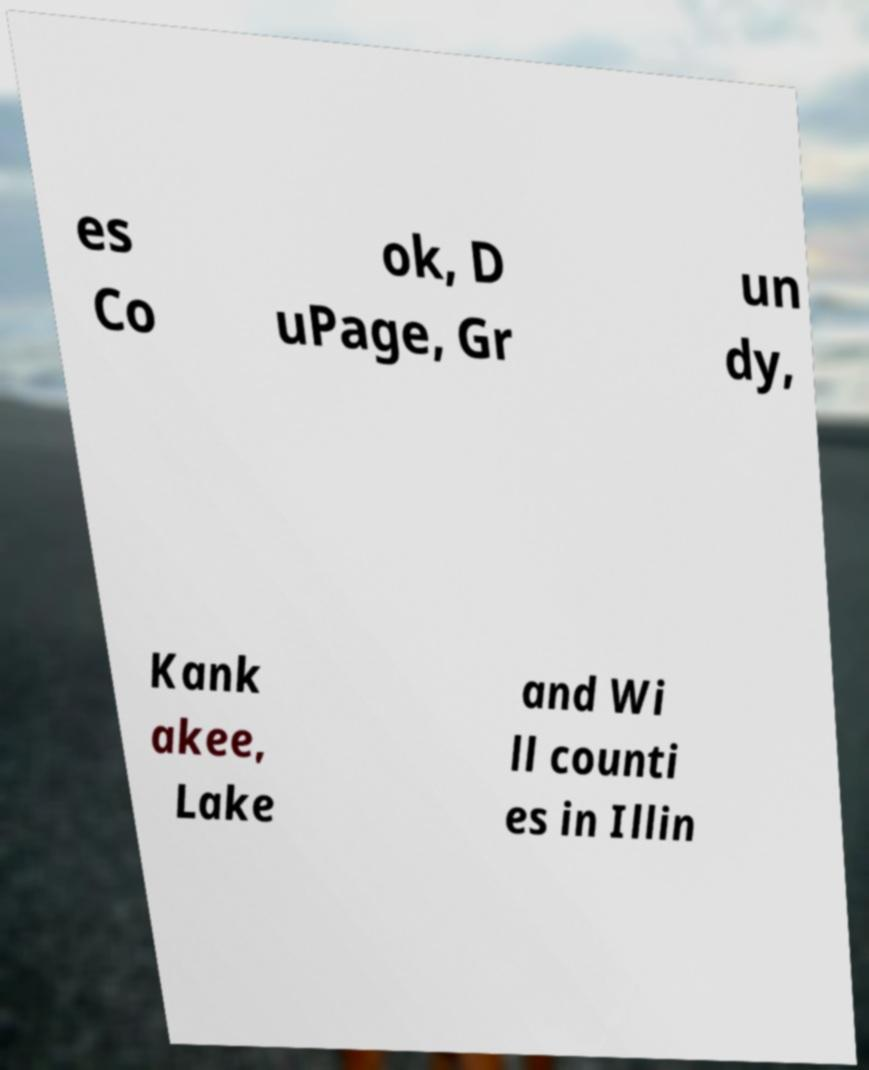Could you extract and type out the text from this image? es Co ok, D uPage, Gr un dy, Kank akee, Lake and Wi ll counti es in Illin 